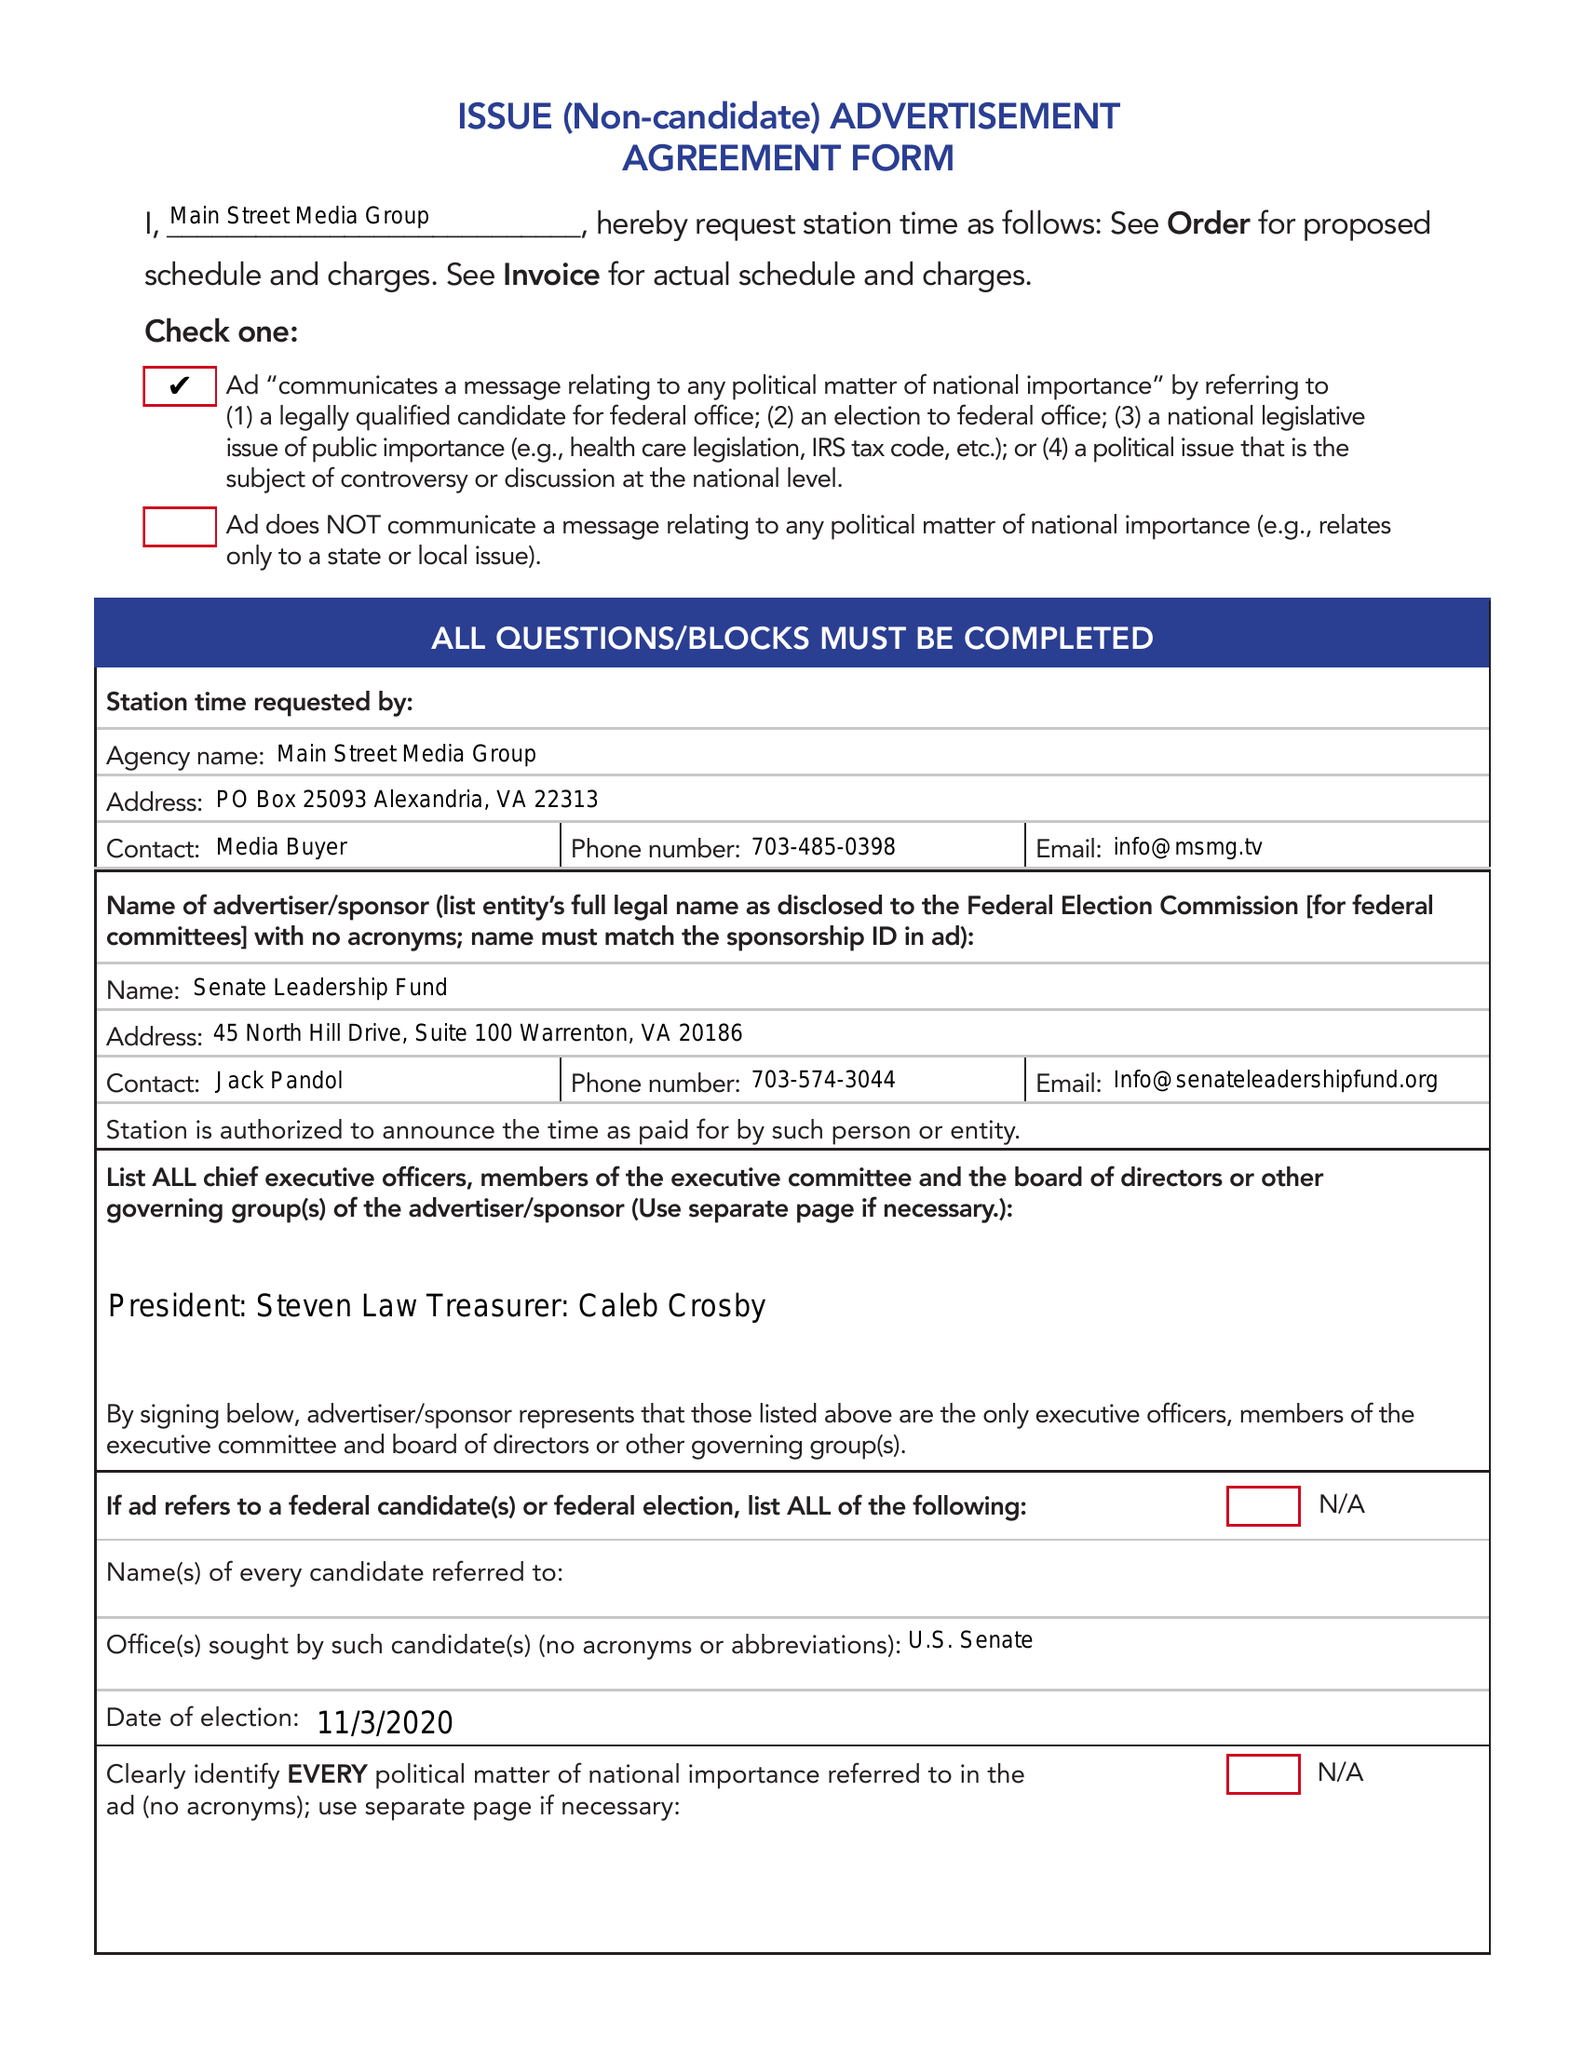What is the value for the gross_amount?
Answer the question using a single word or phrase. None 